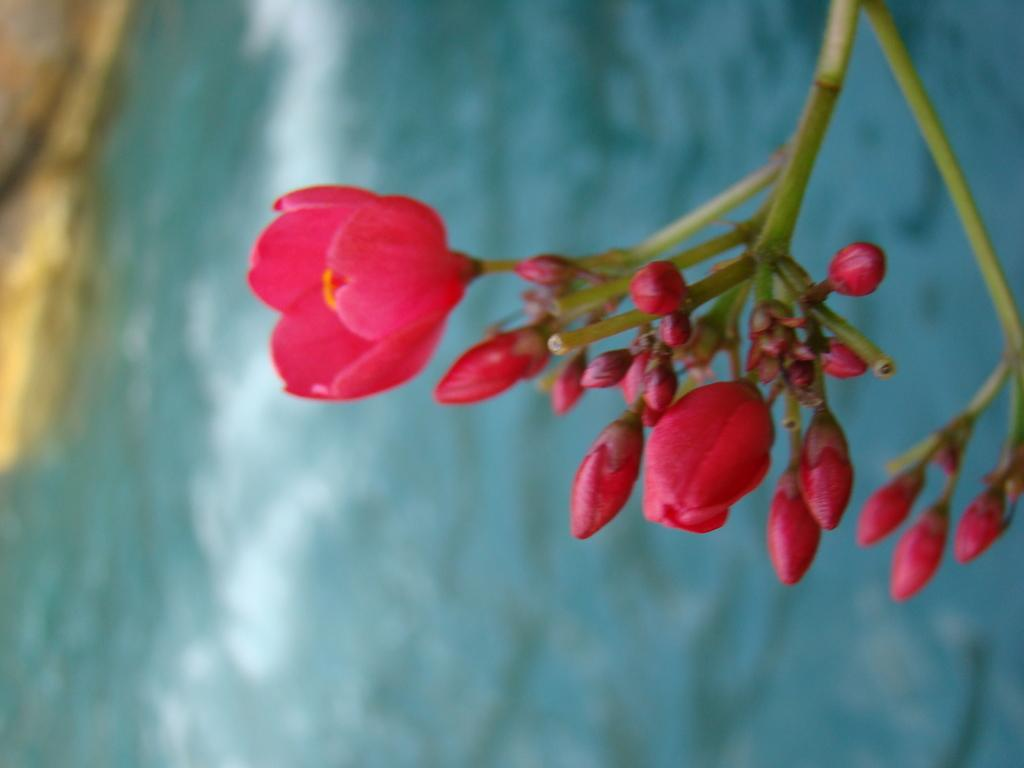What type of living organism can be seen in the image? There is a plant in the image. Can you describe the plant in the image? The plant has many flowers and buds. What natural feature is visible in the image? There is a lake in the image. What object can be seen at the left side of the image? There is a rock at the left side of the image. What type of jeans is the family wearing in the image? There is no family or jeans present in the image; it features a plant, a lake, and a rock. 